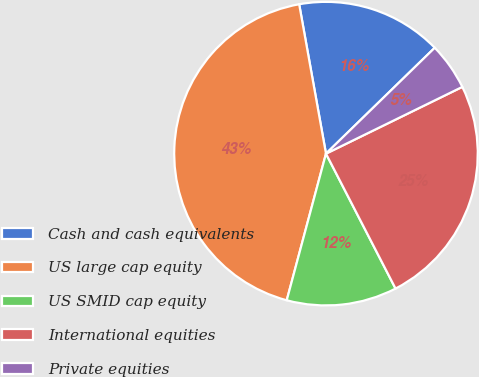Convert chart. <chart><loc_0><loc_0><loc_500><loc_500><pie_chart><fcel>Cash and cash equivalents<fcel>US large cap equity<fcel>US SMID cap equity<fcel>International equities<fcel>Private equities<nl><fcel>15.54%<fcel>43.01%<fcel>11.74%<fcel>24.67%<fcel>5.04%<nl></chart> 